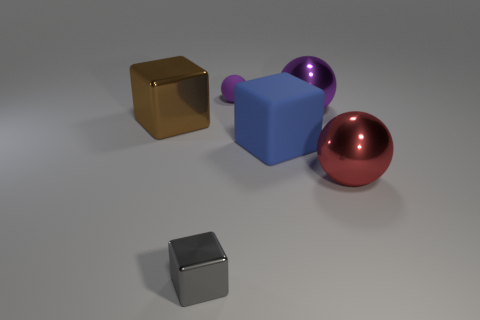Is the size of the shiny thing behind the brown metallic object the same as the tiny purple ball?
Provide a succinct answer. No. What is the size of the sphere that is both in front of the purple rubber object and behind the matte block?
Provide a succinct answer. Large. What number of other objects are there of the same shape as the small purple rubber thing?
Offer a terse response. 2. How many other things are the same material as the gray cube?
Offer a very short reply. 3. What is the size of the gray object that is the same shape as the big brown object?
Your answer should be compact. Small. There is a sphere that is both behind the big blue rubber cube and to the right of the small purple rubber object; what is its color?
Give a very brief answer. Purple. How many objects are either tiny metal cubes to the left of the big blue matte cube or cubes?
Offer a terse response. 3. There is another big thing that is the same shape as the blue rubber object; what is its color?
Your response must be concise. Brown. Does the large red thing have the same shape as the large metallic object that is left of the large rubber cube?
Offer a terse response. No. How many things are either big brown blocks left of the rubber sphere or big purple metal balls that are left of the red ball?
Offer a terse response. 2. 